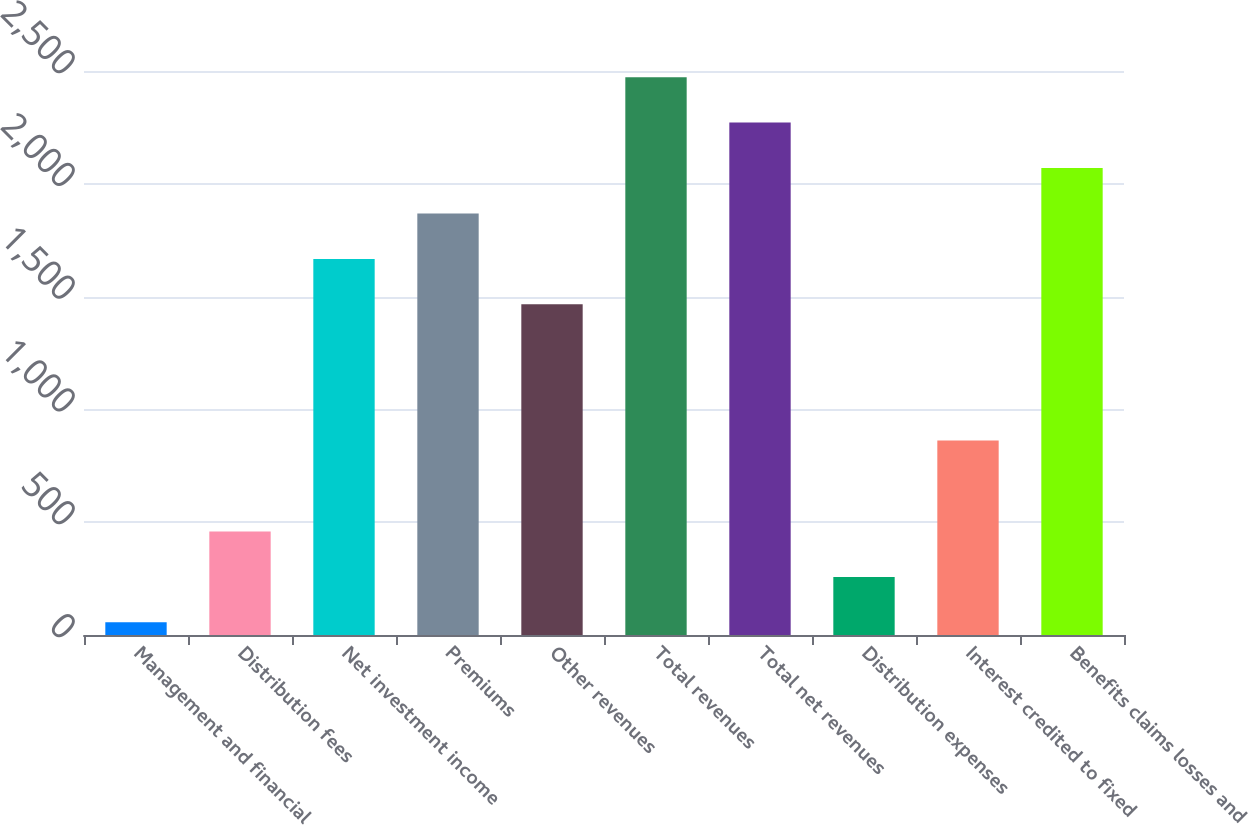Convert chart. <chart><loc_0><loc_0><loc_500><loc_500><bar_chart><fcel>Management and financial<fcel>Distribution fees<fcel>Net investment income<fcel>Premiums<fcel>Other revenues<fcel>Total revenues<fcel>Total net revenues<fcel>Distribution expenses<fcel>Interest credited to fixed<fcel>Benefits claims losses and<nl><fcel>56<fcel>458.8<fcel>1667.2<fcel>1868.6<fcel>1465.8<fcel>2472.8<fcel>2271.4<fcel>257.4<fcel>861.6<fcel>2070<nl></chart> 